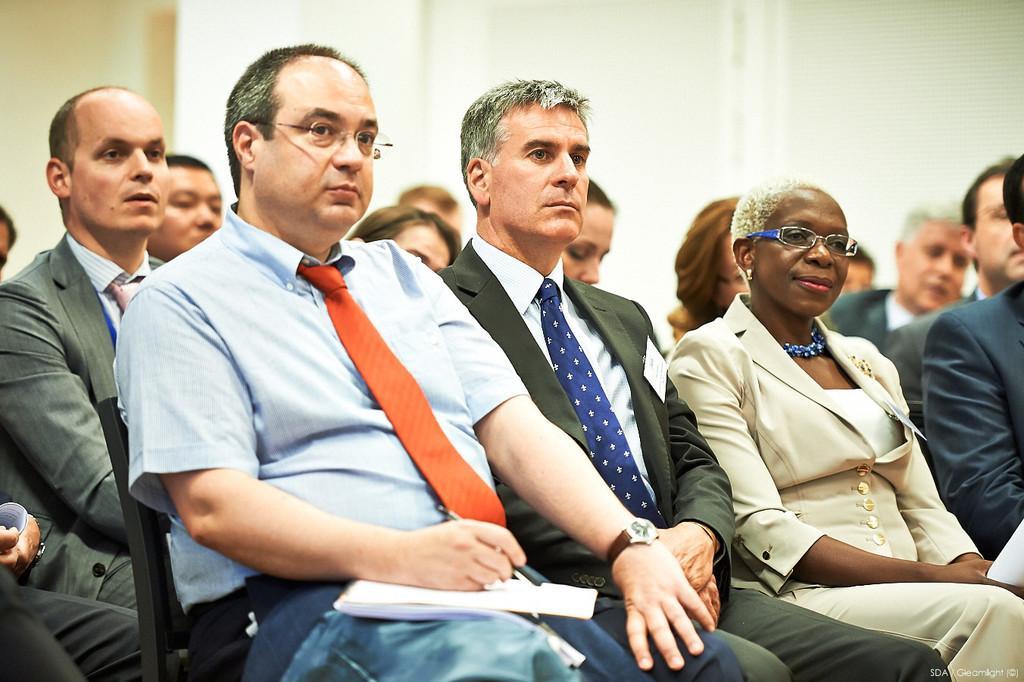Describe this image in one or two sentences. In this image we can see a group of people sitting on the chairs. In that a man is holding some papers and a pen. On the backside we can see a wall. 